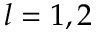<formula> <loc_0><loc_0><loc_500><loc_500>l = 1 , 2</formula> 